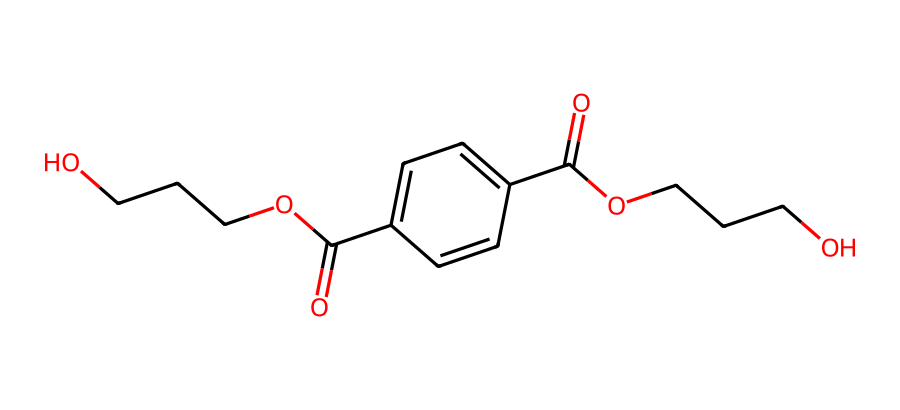What is the main functional group in this chemical? The structure contains carbonyl groups (C=O) and hydroxyl groups (–OH), indicating it has ester and acid functionalities, but the main functional group is the ester group formed by the bonding of the hydroxyl and carbonyl from the acids and alcohols present.
Answer: ester How many carbon atoms are in this molecule? By analyzing the SMILES representation, counting the carbon atoms indicated within the structure results in a total of 14 carbon atoms.
Answer: 14 What type of polymer does this molecule represent? The molecule's structure represents polyethylene terephthalate (PET), which is a common thermoplastic polymer used in various applications, including plastic bottles and fibers.
Answer: thermoplastic What is the total number of individual oxygen atoms in the molecule? A close inspection of the SMILES representation shows there are four oxygen atoms, indicated by the ‘O’ in both the ester groups and the hydroxyl groups.
Answer: 4 Does this material degrade easily? Polyethylene terephthalate (PET) is known for its durability and resistance to degradation, which is one reason it is widely used for packaging and storage.
Answer: no 